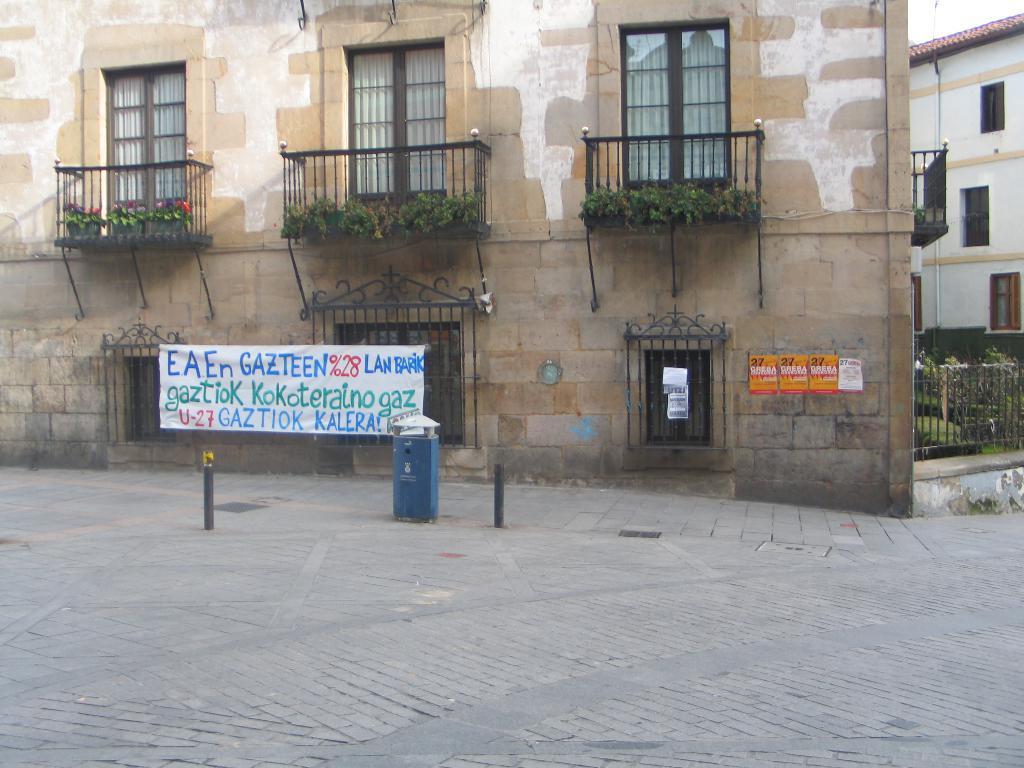In one or two sentences, can you explain what this image depicts? In this image I can see two building with windows and the railing. In-front of the building I can see the banner and the boards to the wall. I can also see the dustbin. To the right I can see the plants and the railing. In the background I can see the sky. 